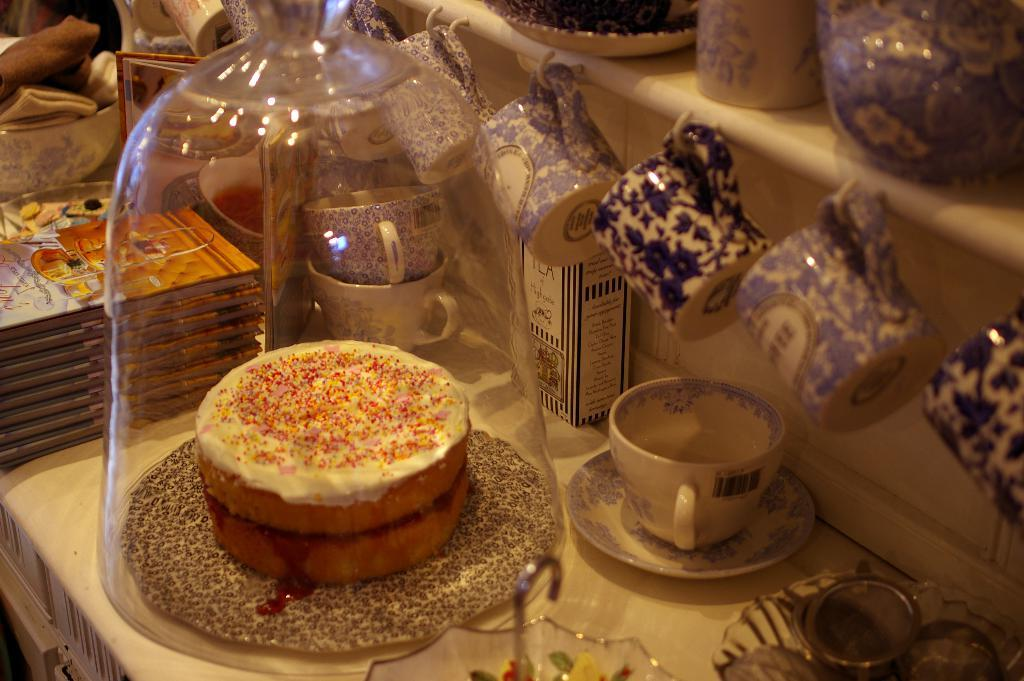What type of pastry is in the glass jar in the image? There is a cream doughnut in the glass jar in the image. What can be seen hanging on the hook in the background? There are blue color tea cups hanging on the hook in the background. How many buttons can be seen on the cream doughnut in the image? There are no buttons present on the cream doughnut in the image. 